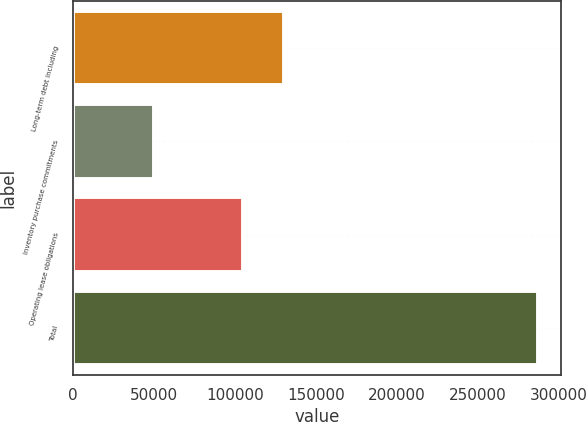Convert chart to OTSL. <chart><loc_0><loc_0><loc_500><loc_500><bar_chart><fcel>Long-term debt including<fcel>Inventory purchase commitments<fcel>Operating lease obligations<fcel>Total<nl><fcel>130290<fcel>50329<fcel>104972<fcel>287076<nl></chart> 